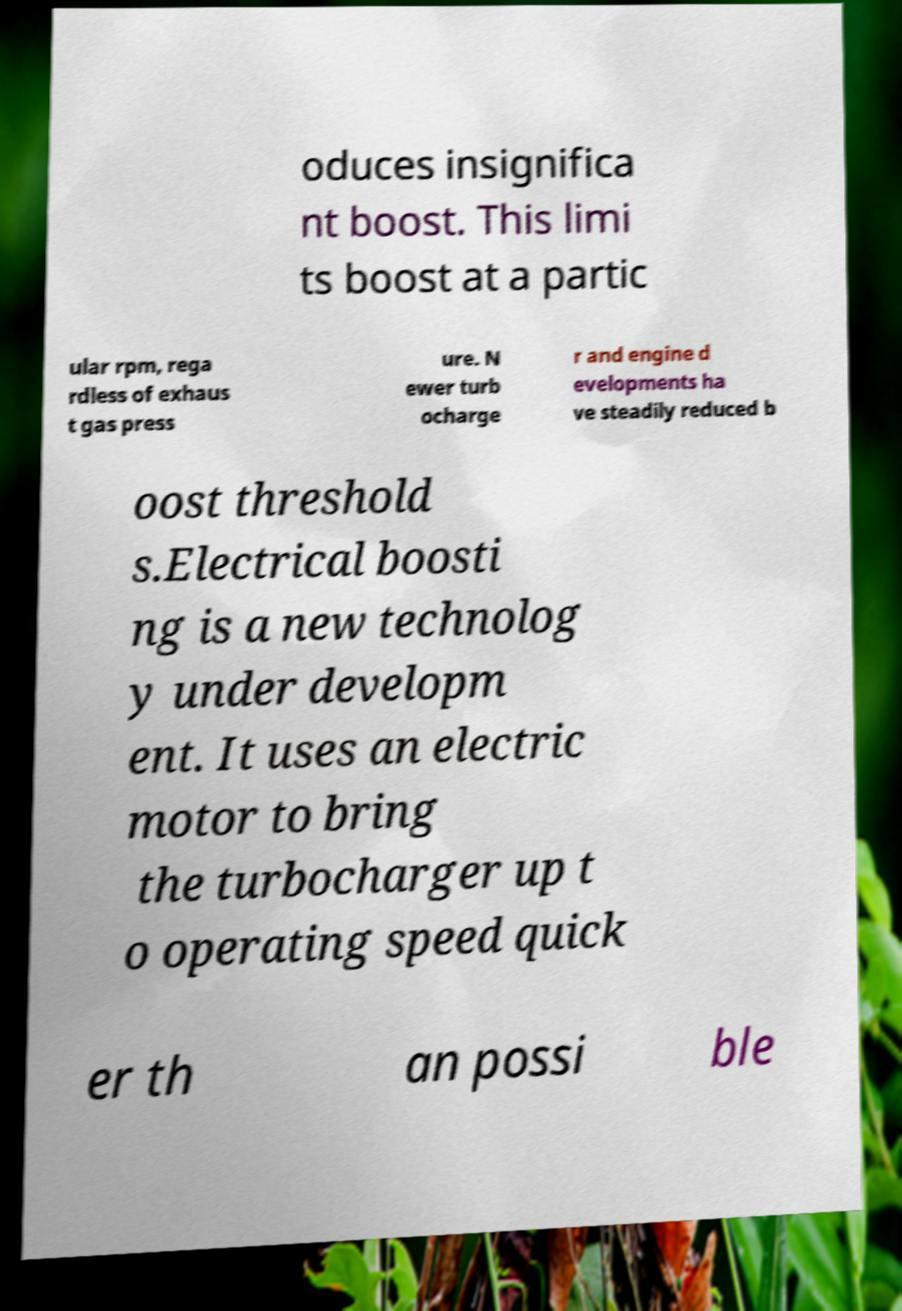Please identify and transcribe the text found in this image. oduces insignifica nt boost. This limi ts boost at a partic ular rpm, rega rdless of exhaus t gas press ure. N ewer turb ocharge r and engine d evelopments ha ve steadily reduced b oost threshold s.Electrical boosti ng is a new technolog y under developm ent. It uses an electric motor to bring the turbocharger up t o operating speed quick er th an possi ble 